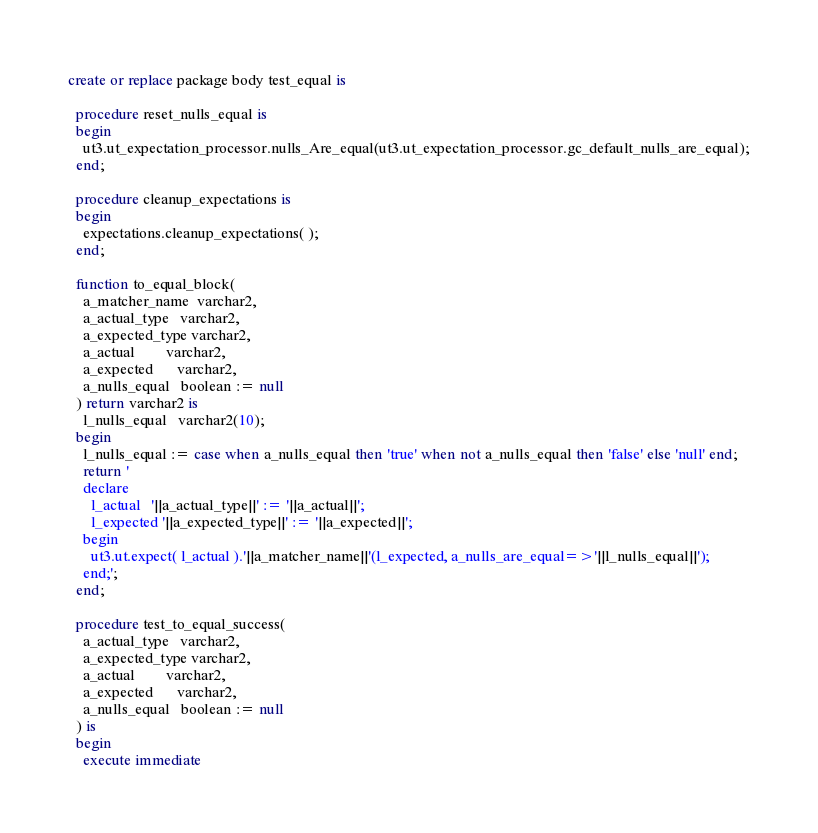<code> <loc_0><loc_0><loc_500><loc_500><_SQL_>create or replace package body test_equal is

  procedure reset_nulls_equal is
  begin
    ut3.ut_expectation_processor.nulls_Are_equal(ut3.ut_expectation_processor.gc_default_nulls_are_equal);
  end;

  procedure cleanup_expectations is
  begin
    expectations.cleanup_expectations( );
  end;

  function to_equal_block(
    a_matcher_name  varchar2,
    a_actual_type   varchar2,
    a_expected_type varchar2,
    a_actual        varchar2,
    a_expected      varchar2,
    a_nulls_equal   boolean := null
  ) return varchar2 is
    l_nulls_equal   varchar2(10);
  begin
    l_nulls_equal := case when a_nulls_equal then 'true' when not a_nulls_equal then 'false' else 'null' end;
    return '
    declare
      l_actual   '||a_actual_type||' := '||a_actual||';
      l_expected '||a_expected_type||' := '||a_expected||';
    begin
      ut3.ut.expect( l_actual ).'||a_matcher_name||'(l_expected, a_nulls_are_equal=>'||l_nulls_equal||');
    end;';
  end;

  procedure test_to_equal_success(
    a_actual_type   varchar2,
    a_expected_type varchar2,
    a_actual        varchar2,
    a_expected      varchar2,
    a_nulls_equal   boolean := null
  ) is
  begin
    execute immediate</code> 